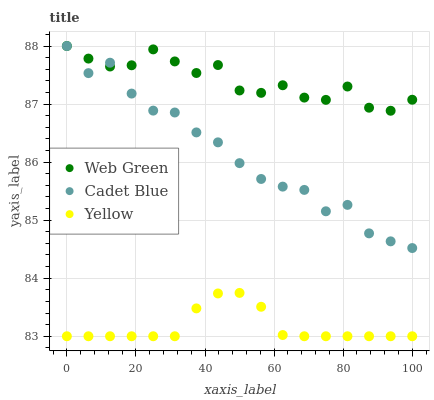Does Yellow have the minimum area under the curve?
Answer yes or no. Yes. Does Web Green have the maximum area under the curve?
Answer yes or no. Yes. Does Web Green have the minimum area under the curve?
Answer yes or no. No. Does Yellow have the maximum area under the curve?
Answer yes or no. No. Is Yellow the smoothest?
Answer yes or no. Yes. Is Cadet Blue the roughest?
Answer yes or no. Yes. Is Web Green the smoothest?
Answer yes or no. No. Is Web Green the roughest?
Answer yes or no. No. Does Yellow have the lowest value?
Answer yes or no. Yes. Does Web Green have the lowest value?
Answer yes or no. No. Does Web Green have the highest value?
Answer yes or no. Yes. Does Yellow have the highest value?
Answer yes or no. No. Is Yellow less than Cadet Blue?
Answer yes or no. Yes. Is Web Green greater than Yellow?
Answer yes or no. Yes. Does Cadet Blue intersect Web Green?
Answer yes or no. Yes. Is Cadet Blue less than Web Green?
Answer yes or no. No. Is Cadet Blue greater than Web Green?
Answer yes or no. No. Does Yellow intersect Cadet Blue?
Answer yes or no. No. 